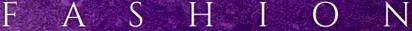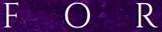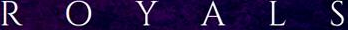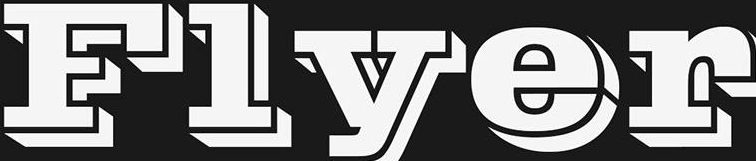Read the text content from these images in order, separated by a semicolon. FASHION; FOR; ROYALS; Flyer 